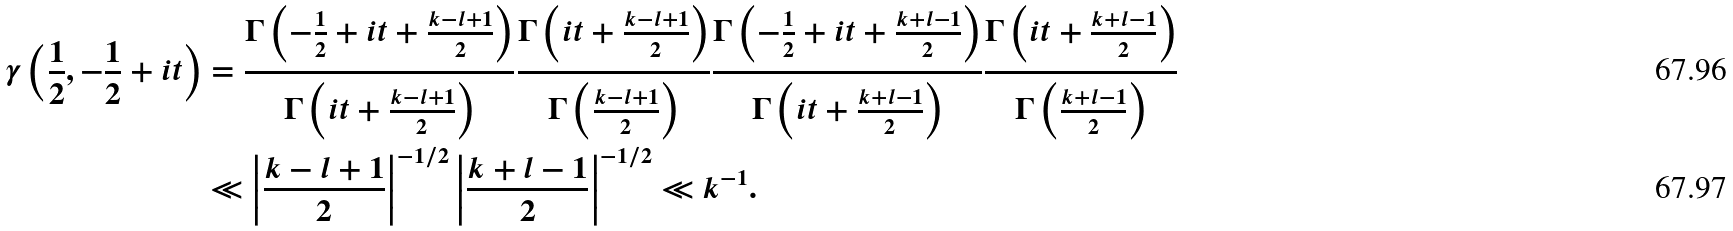<formula> <loc_0><loc_0><loc_500><loc_500>\gamma \left ( \frac { 1 } { 2 } , - \frac { 1 } { 2 } + i t \right ) & = \frac { \Gamma \left ( - \frac { 1 } { 2 } + i t + \frac { k - l + 1 } { 2 } \right ) } { \Gamma \left ( i t + \frac { k - l + 1 } { 2 } \right ) } \frac { \Gamma \left ( i t + \frac { k - l + 1 } { 2 } \right ) } { \Gamma \left ( \frac { k - l + 1 } { 2 } \right ) } \frac { \Gamma \left ( - \frac { 1 } { 2 } + i t + \frac { k + l - 1 } { 2 } \right ) } { \Gamma \left ( i t + \frac { k + l - 1 } { 2 } \right ) } \frac { \Gamma \left ( i t + \frac { k + l - 1 } { 2 } \right ) } { \Gamma \left ( \frac { k + l - 1 } { 2 } \right ) } \\ & \ll \left | \frac { k - l + 1 } { 2 } \right | ^ { - 1 / 2 } \left | \frac { k + l - 1 } { 2 } \right | ^ { - 1 / 2 } \ll { k } ^ { - 1 } .</formula> 